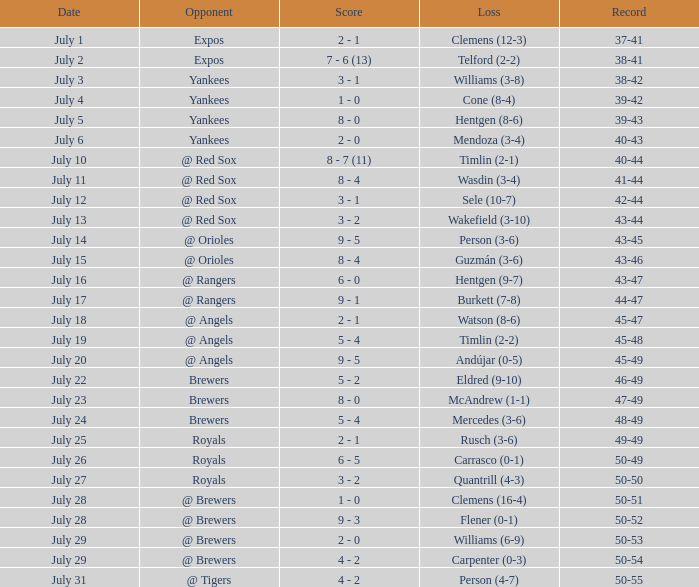What's the documentation for july 10? 40-44. Could you help me parse every detail presented in this table? {'header': ['Date', 'Opponent', 'Score', 'Loss', 'Record'], 'rows': [['July 1', 'Expos', '2 - 1', 'Clemens (12-3)', '37-41'], ['July 2', 'Expos', '7 - 6 (13)', 'Telford (2-2)', '38-41'], ['July 3', 'Yankees', '3 - 1', 'Williams (3-8)', '38-42'], ['July 4', 'Yankees', '1 - 0', 'Cone (8-4)', '39-42'], ['July 5', 'Yankees', '8 - 0', 'Hentgen (8-6)', '39-43'], ['July 6', 'Yankees', '2 - 0', 'Mendoza (3-4)', '40-43'], ['July 10', '@ Red Sox', '8 - 7 (11)', 'Timlin (2-1)', '40-44'], ['July 11', '@ Red Sox', '8 - 4', 'Wasdin (3-4)', '41-44'], ['July 12', '@ Red Sox', '3 - 1', 'Sele (10-7)', '42-44'], ['July 13', '@ Red Sox', '3 - 2', 'Wakefield (3-10)', '43-44'], ['July 14', '@ Orioles', '9 - 5', 'Person (3-6)', '43-45'], ['July 15', '@ Orioles', '8 - 4', 'Guzmán (3-6)', '43-46'], ['July 16', '@ Rangers', '6 - 0', 'Hentgen (9-7)', '43-47'], ['July 17', '@ Rangers', '9 - 1', 'Burkett (7-8)', '44-47'], ['July 18', '@ Angels', '2 - 1', 'Watson (8-6)', '45-47'], ['July 19', '@ Angels', '5 - 4', 'Timlin (2-2)', '45-48'], ['July 20', '@ Angels', '9 - 5', 'Andújar (0-5)', '45-49'], ['July 22', 'Brewers', '5 - 2', 'Eldred (9-10)', '46-49'], ['July 23', 'Brewers', '8 - 0', 'McAndrew (1-1)', '47-49'], ['July 24', 'Brewers', '5 - 4', 'Mercedes (3-6)', '48-49'], ['July 25', 'Royals', '2 - 1', 'Rusch (3-6)', '49-49'], ['July 26', 'Royals', '6 - 5', 'Carrasco (0-1)', '50-49'], ['July 27', 'Royals', '3 - 2', 'Quantrill (4-3)', '50-50'], ['July 28', '@ Brewers', '1 - 0', 'Clemens (16-4)', '50-51'], ['July 28', '@ Brewers', '9 - 3', 'Flener (0-1)', '50-52'], ['July 29', '@ Brewers', '2 - 0', 'Williams (6-9)', '50-53'], ['July 29', '@ Brewers', '4 - 2', 'Carpenter (0-3)', '50-54'], ['July 31', '@ Tigers', '4 - 2', 'Person (4-7)', '50-55']]} 